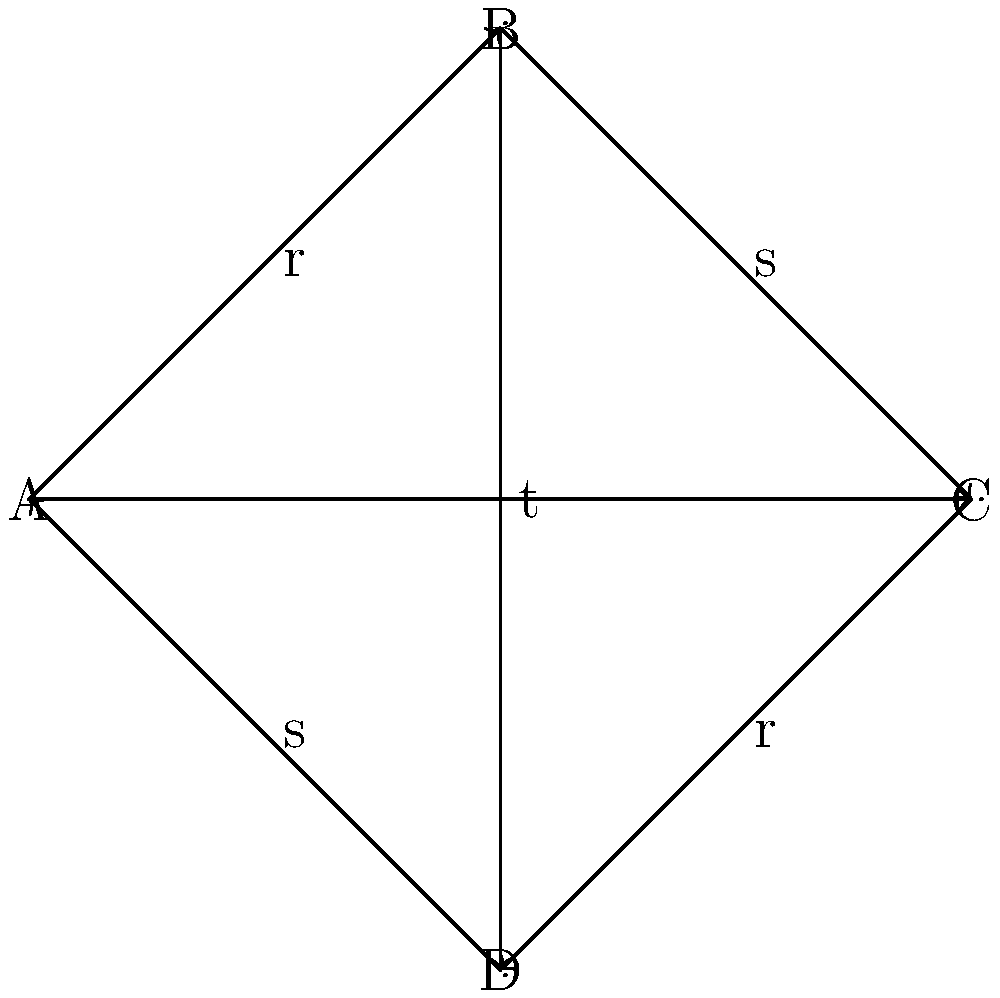Consider the Cayley diagram representing various stages of rehabilitation after a spinal cord injury. The nodes A, B, C, and D represent different levels of recovery, while the edges r, s, and t represent specific rehabilitation exercises or treatments. Identify all proper subgroups of this group and determine which subgroup represents the most effective rehabilitation path. To solve this problem, let's follow these steps:

1) First, we need to identify the group structure. This Cayley diagram represents a group of order 4, which is isomorphic to the Klein four-group $V_4$.

2) The generators of the group are:
   r: A → B → C → D → A
   s: A → D → C → B → A
   t: A → C, B → D

3) To find all proper subgroups, we need to look for closed subsets of elements:

   a) Subgroups of order 2:
      {A, B} generated by r²
      {A, C} generated by t
      {A, D} generated by s²

   b) There are no subgroups of order 3 as 3 doesn't divide the order of the group (4).

4) Now, let's interpret these subgroups in terms of rehabilitation:

   {A, B}: Represents alternating between initial state and moderate improvement.
   {A, C}: Represents direct transition between initial state and significant improvement.
   {A, D}: Represents alternating between initial state and advanced recovery.

5) To determine the most effective rehabilitation path, we need to consider which subgroup allows for the most significant improvement with the least number of transitions.

6) The subgroup {A, C} allows for direct transition between the initial state and significant improvement using the treatment t. This represents the most efficient path as it achieves significant improvement in a single step.

Therefore, the subgroup {A, C} generated by t represents the most effective rehabilitation path.
Answer: {A, C} generated by t 